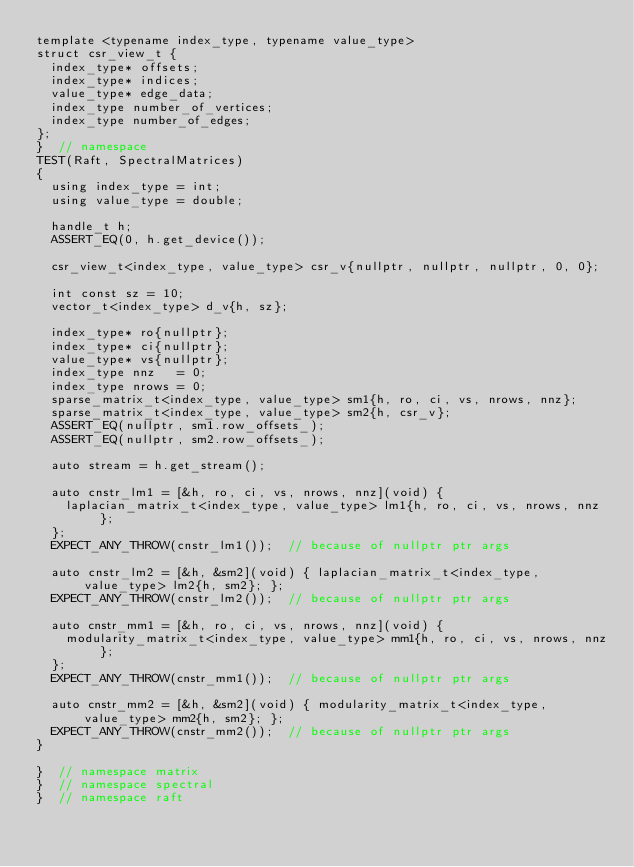<code> <loc_0><loc_0><loc_500><loc_500><_Cuda_>template <typename index_type, typename value_type>
struct csr_view_t {
  index_type* offsets;
  index_type* indices;
  value_type* edge_data;
  index_type number_of_vertices;
  index_type number_of_edges;
};
}  // namespace
TEST(Raft, SpectralMatrices)
{
  using index_type = int;
  using value_type = double;

  handle_t h;
  ASSERT_EQ(0, h.get_device());

  csr_view_t<index_type, value_type> csr_v{nullptr, nullptr, nullptr, 0, 0};

  int const sz = 10;
  vector_t<index_type> d_v{h, sz};

  index_type* ro{nullptr};
  index_type* ci{nullptr};
  value_type* vs{nullptr};
  index_type nnz   = 0;
  index_type nrows = 0;
  sparse_matrix_t<index_type, value_type> sm1{h, ro, ci, vs, nrows, nnz};
  sparse_matrix_t<index_type, value_type> sm2{h, csr_v};
  ASSERT_EQ(nullptr, sm1.row_offsets_);
  ASSERT_EQ(nullptr, sm2.row_offsets_);

  auto stream = h.get_stream();

  auto cnstr_lm1 = [&h, ro, ci, vs, nrows, nnz](void) {
    laplacian_matrix_t<index_type, value_type> lm1{h, ro, ci, vs, nrows, nnz};
  };
  EXPECT_ANY_THROW(cnstr_lm1());  // because of nullptr ptr args

  auto cnstr_lm2 = [&h, &sm2](void) { laplacian_matrix_t<index_type, value_type> lm2{h, sm2}; };
  EXPECT_ANY_THROW(cnstr_lm2());  // because of nullptr ptr args

  auto cnstr_mm1 = [&h, ro, ci, vs, nrows, nnz](void) {
    modularity_matrix_t<index_type, value_type> mm1{h, ro, ci, vs, nrows, nnz};
  };
  EXPECT_ANY_THROW(cnstr_mm1());  // because of nullptr ptr args

  auto cnstr_mm2 = [&h, &sm2](void) { modularity_matrix_t<index_type, value_type> mm2{h, sm2}; };
  EXPECT_ANY_THROW(cnstr_mm2());  // because of nullptr ptr args
}

}  // namespace matrix
}  // namespace spectral
}  // namespace raft
</code> 